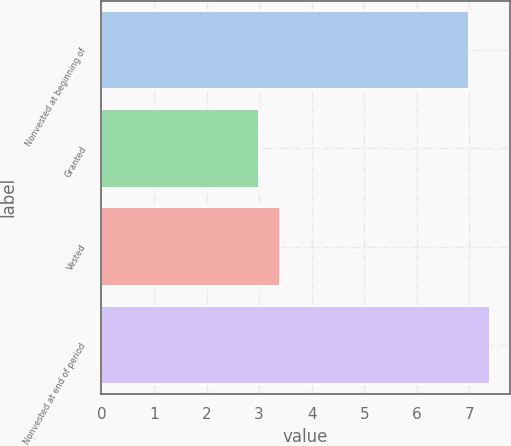Convert chart to OTSL. <chart><loc_0><loc_0><loc_500><loc_500><bar_chart><fcel>Nonvested at beginning of<fcel>Granted<fcel>Vested<fcel>Nonvested at end of period<nl><fcel>7<fcel>3<fcel>3.4<fcel>7.4<nl></chart> 